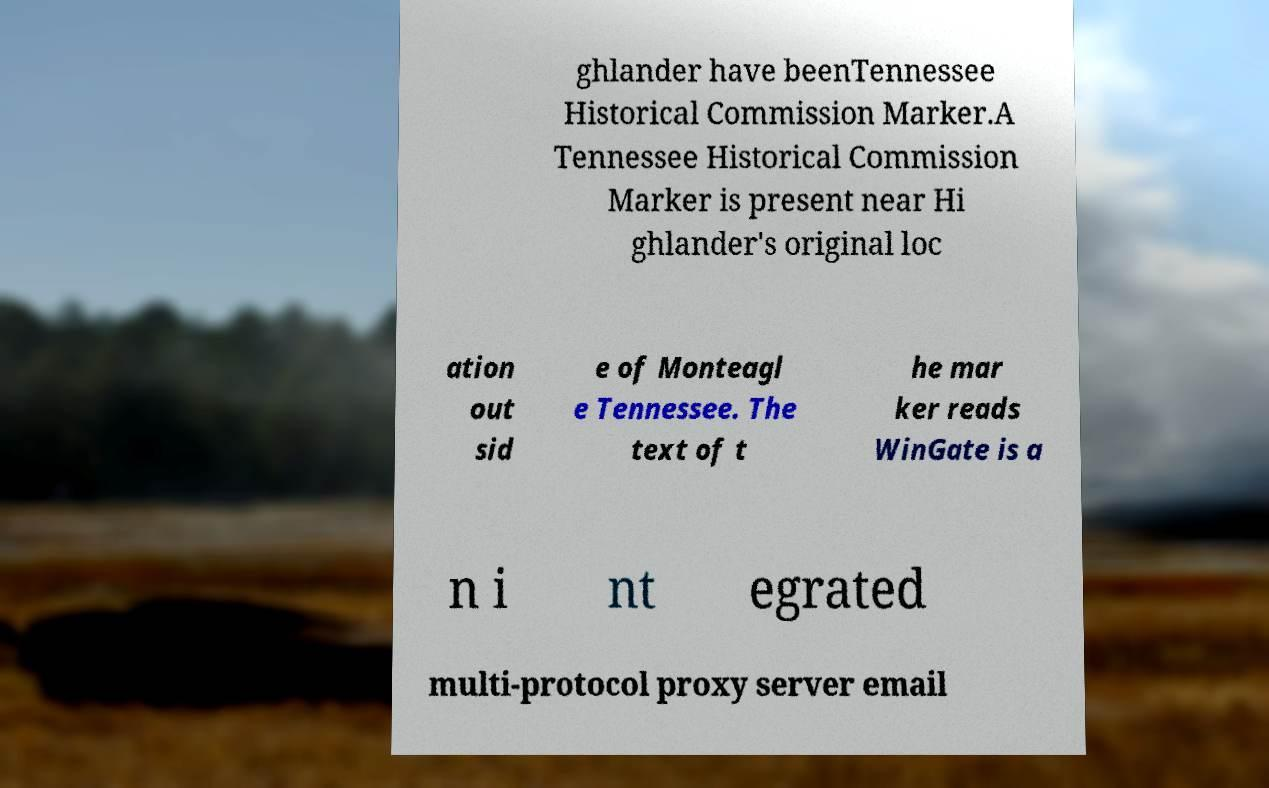Can you read and provide the text displayed in the image?This photo seems to have some interesting text. Can you extract and type it out for me? ghlander have beenTennessee Historical Commission Marker.A Tennessee Historical Commission Marker is present near Hi ghlander's original loc ation out sid e of Monteagl e Tennessee. The text of t he mar ker reads WinGate is a n i nt egrated multi-protocol proxy server email 